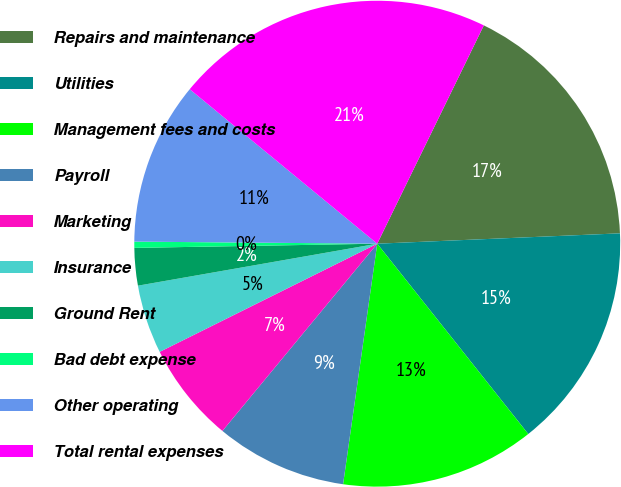Convert chart to OTSL. <chart><loc_0><loc_0><loc_500><loc_500><pie_chart><fcel>Repairs and maintenance<fcel>Utilities<fcel>Management fees and costs<fcel>Payroll<fcel>Marketing<fcel>Insurance<fcel>Ground Rent<fcel>Bad debt expense<fcel>Other operating<fcel>Total rental expenses<nl><fcel>17.09%<fcel>15.0%<fcel>12.92%<fcel>8.75%<fcel>6.66%<fcel>4.58%<fcel>2.49%<fcel>0.41%<fcel>10.83%<fcel>21.26%<nl></chart> 